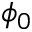<formula> <loc_0><loc_0><loc_500><loc_500>\phi _ { 0 }</formula> 